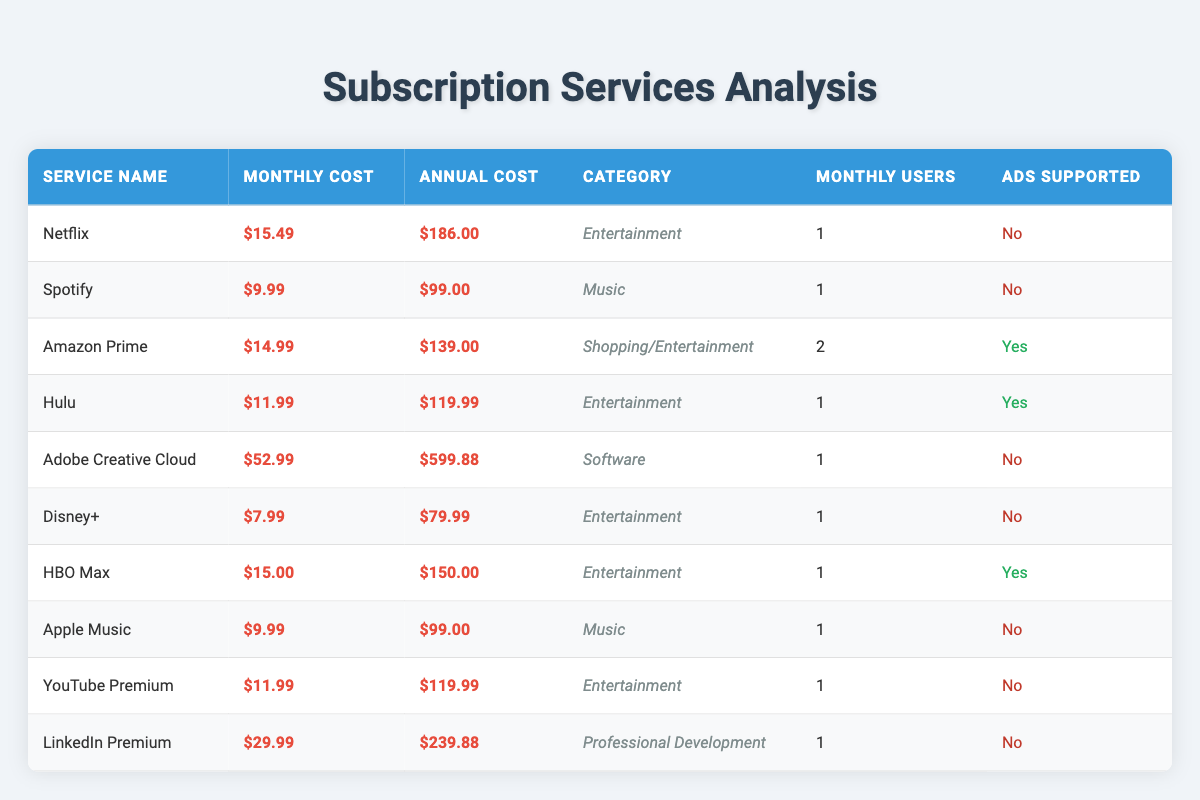What is the monthly cost of Netflix? The table lists Netflix under "Service Name" with a corresponding "Monthly Cost" of $15.49.
Answer: $15.49 How many services are in the Entertainment category? By looking at the "Category" column, we can identify that there are five services labeled as Entertainment: Netflix, Hulu, Disney+, HBO Max, and YouTube Premium.
Answer: 5 What is the total annual cost of all the subscription services? We sum the "Annual Cost" values for all services: $186.00 + $99.00 + $139.00 + $119.99 + $599.88 + $79.99 + $150.00 + $99.00 + $119.99 + $239.88 = $1,793.61.
Answer: $1,793.61 Is Amazon Prime ads supported? The table specifies that Amazon Prime's "Ads Supported" status is labeled as "Yes."
Answer: Yes What is the average monthly cost of Music subscription services? There are two Music services: Spotify and Apple Music with costs of $9.99 each. Adding these together gives $9.99 + $9.99 = $19.98, and dividing by 2 gives an average of $9.99.
Answer: $9.99 How many services have a monthly cost greater than $20? Reviewing the "Monthly Cost" column shows that only Adobe Creative Cloud ($52.99) and LinkedIn Premium ($29.99) exceed $20. Therefore, the count is 2.
Answer: 2 What is the annual cost difference between Hulu and HBO Max? The annual cost of Hulu is $119.99 and HBO Max is $150.00. Calculating the difference: $150.00 - $119.99 = $30.01.
Answer: $30.01 Are there any services that charge a monthly cost below $10? By referencing the "Monthly Cost" column, we see that Disney+ at $7.99 meets this criterion; therefore, the answer is "Yes."
Answer: Yes What is the combined monthly cost of all subscriptions with ads supported? The services with ads supported are Amazon Prime ($14.99), Hulu ($11.99), and HBO Max ($15.00). Summing these gives $14.99 + $11.99 + $15.00 = $41.98.
Answer: $41.98 